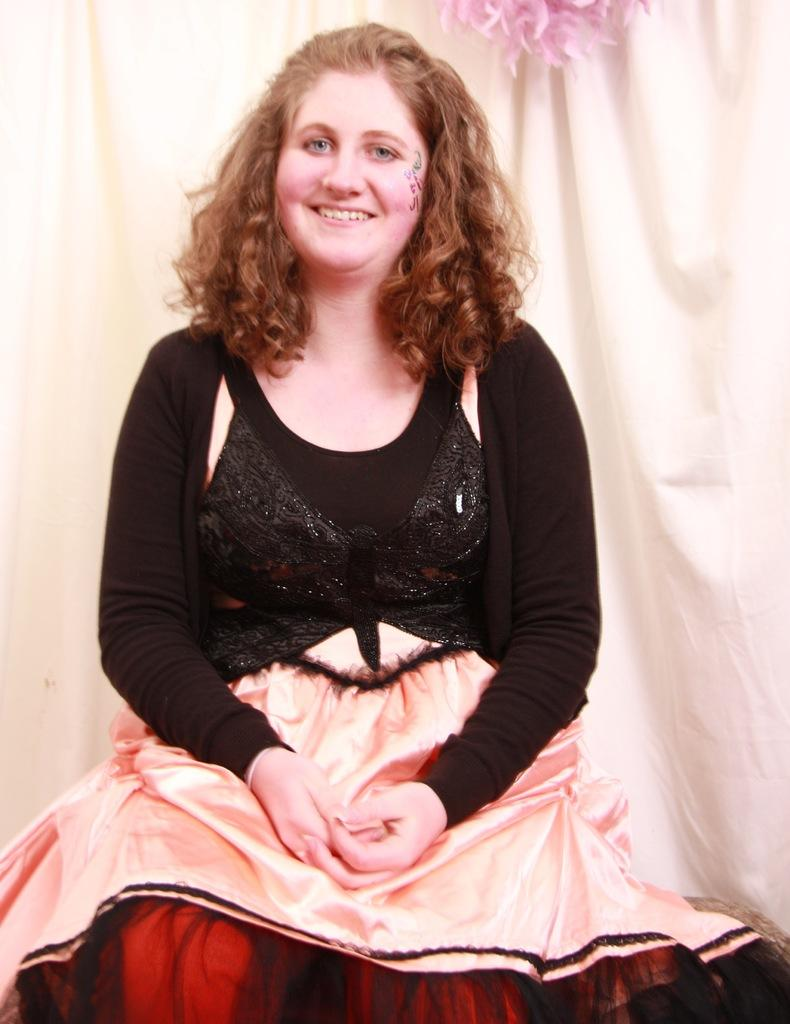What is the person in the image doing? The person is sitting in the image. What color is the top the person is wearing? The person is wearing a black top. What type of clothing is the person wearing on the bottom? The person is wearing a skirt. What can be seen behind the person in the image? There is a curtain behind the person. How many industries can be seen in the image? There are no industries present in the image. What type of nest is visible in the image? There is no nest visible in the image. 